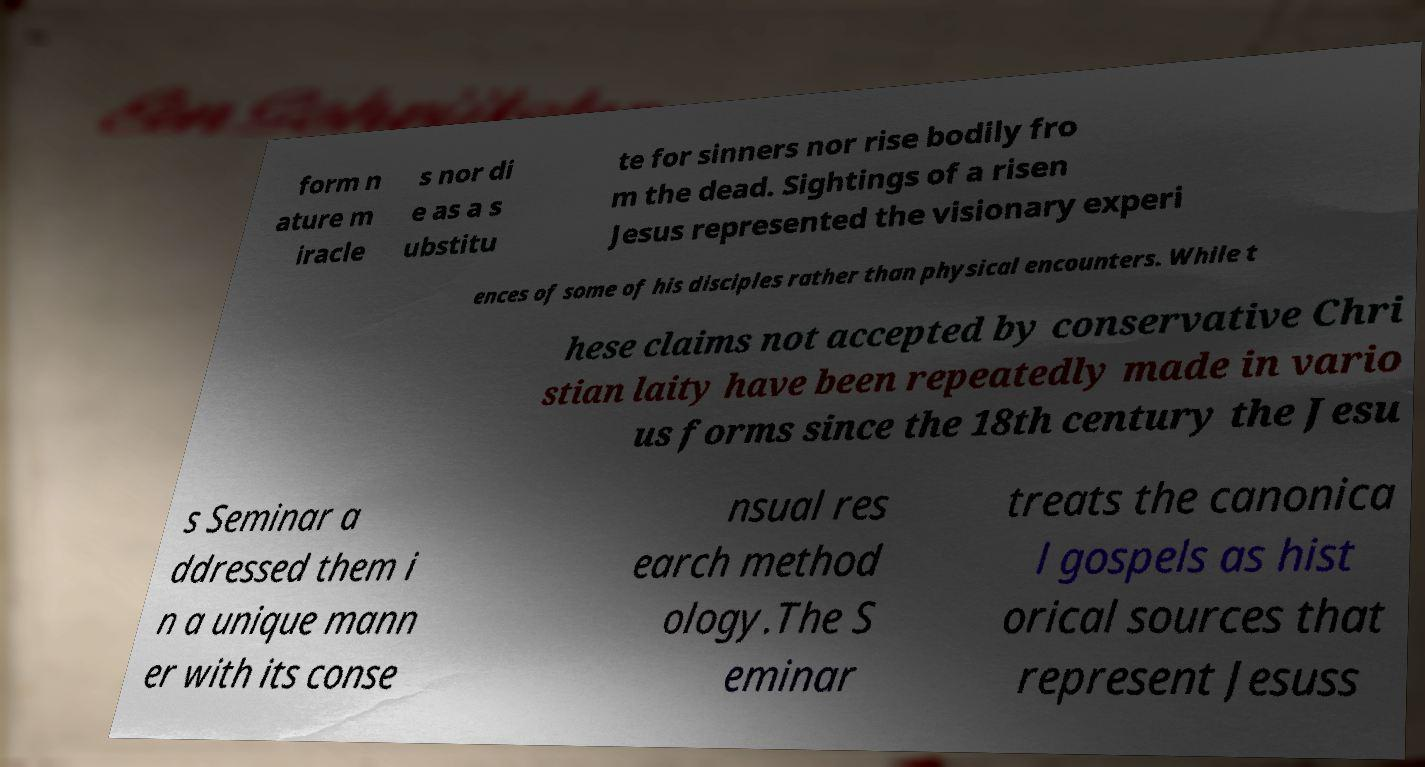Can you accurately transcribe the text from the provided image for me? form n ature m iracle s nor di e as a s ubstitu te for sinners nor rise bodily fro m the dead. Sightings of a risen Jesus represented the visionary experi ences of some of his disciples rather than physical encounters. While t hese claims not accepted by conservative Chri stian laity have been repeatedly made in vario us forms since the 18th century the Jesu s Seminar a ddressed them i n a unique mann er with its conse nsual res earch method ology.The S eminar treats the canonica l gospels as hist orical sources that represent Jesuss 